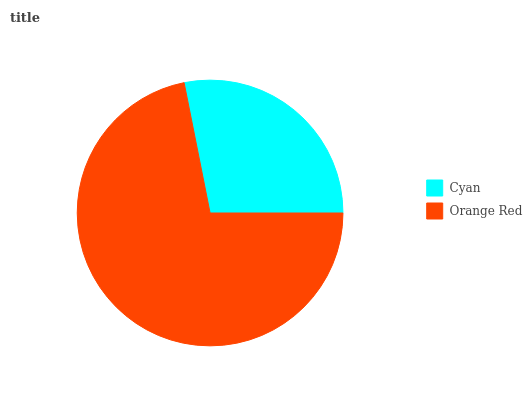Is Cyan the minimum?
Answer yes or no. Yes. Is Orange Red the maximum?
Answer yes or no. Yes. Is Orange Red the minimum?
Answer yes or no. No. Is Orange Red greater than Cyan?
Answer yes or no. Yes. Is Cyan less than Orange Red?
Answer yes or no. Yes. Is Cyan greater than Orange Red?
Answer yes or no. No. Is Orange Red less than Cyan?
Answer yes or no. No. Is Orange Red the high median?
Answer yes or no. Yes. Is Cyan the low median?
Answer yes or no. Yes. Is Cyan the high median?
Answer yes or no. No. Is Orange Red the low median?
Answer yes or no. No. 